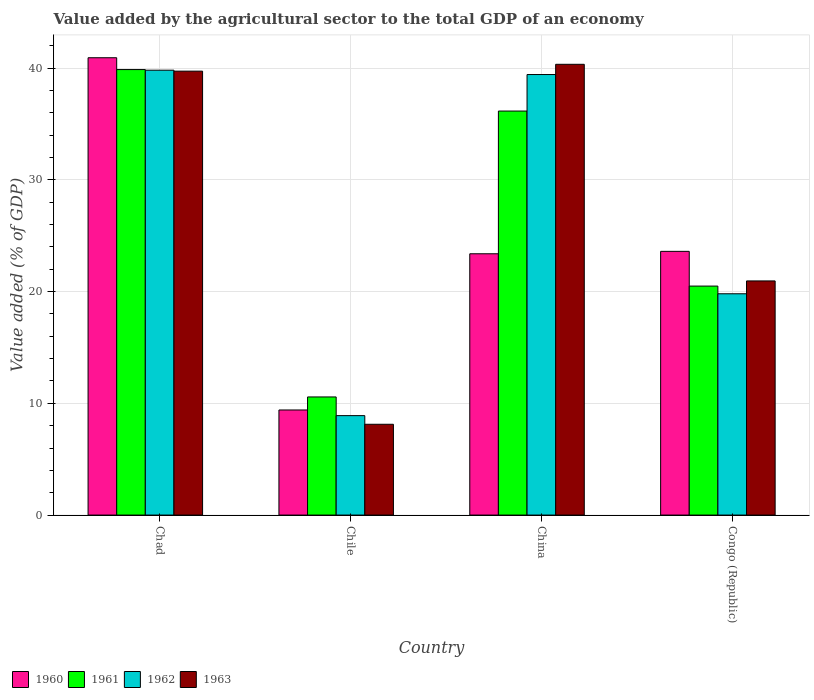How many groups of bars are there?
Provide a short and direct response. 4. How many bars are there on the 1st tick from the right?
Offer a terse response. 4. What is the label of the 1st group of bars from the left?
Provide a succinct answer. Chad. In how many cases, is the number of bars for a given country not equal to the number of legend labels?
Offer a terse response. 0. What is the value added by the agricultural sector to the total GDP in 1963 in Chad?
Provide a short and direct response. 39.73. Across all countries, what is the maximum value added by the agricultural sector to the total GDP in 1961?
Ensure brevity in your answer.  39.87. Across all countries, what is the minimum value added by the agricultural sector to the total GDP in 1963?
Make the answer very short. 8.13. In which country was the value added by the agricultural sector to the total GDP in 1960 maximum?
Your response must be concise. Chad. In which country was the value added by the agricultural sector to the total GDP in 1960 minimum?
Your answer should be compact. Chile. What is the total value added by the agricultural sector to the total GDP in 1962 in the graph?
Your response must be concise. 107.94. What is the difference between the value added by the agricultural sector to the total GDP in 1962 in Chad and that in Chile?
Provide a short and direct response. 30.91. What is the difference between the value added by the agricultural sector to the total GDP in 1963 in Congo (Republic) and the value added by the agricultural sector to the total GDP in 1962 in China?
Keep it short and to the point. -18.47. What is the average value added by the agricultural sector to the total GDP in 1963 per country?
Keep it short and to the point. 27.29. What is the difference between the value added by the agricultural sector to the total GDP of/in 1961 and value added by the agricultural sector to the total GDP of/in 1960 in China?
Give a very brief answer. 12.77. What is the ratio of the value added by the agricultural sector to the total GDP in 1963 in China to that in Congo (Republic)?
Make the answer very short. 1.93. Is the difference between the value added by the agricultural sector to the total GDP in 1961 in Chad and Congo (Republic) greater than the difference between the value added by the agricultural sector to the total GDP in 1960 in Chad and Congo (Republic)?
Your answer should be very brief. Yes. What is the difference between the highest and the second highest value added by the agricultural sector to the total GDP in 1961?
Your answer should be very brief. 15.66. What is the difference between the highest and the lowest value added by the agricultural sector to the total GDP in 1963?
Offer a terse response. 32.21. Is it the case that in every country, the sum of the value added by the agricultural sector to the total GDP in 1962 and value added by the agricultural sector to the total GDP in 1963 is greater than the sum of value added by the agricultural sector to the total GDP in 1961 and value added by the agricultural sector to the total GDP in 1960?
Provide a succinct answer. No. How many countries are there in the graph?
Your response must be concise. 4. What is the difference between two consecutive major ticks on the Y-axis?
Provide a succinct answer. 10. What is the title of the graph?
Give a very brief answer. Value added by the agricultural sector to the total GDP of an economy. Does "2009" appear as one of the legend labels in the graph?
Ensure brevity in your answer.  No. What is the label or title of the X-axis?
Your answer should be compact. Country. What is the label or title of the Y-axis?
Your answer should be compact. Value added (% of GDP). What is the Value added (% of GDP) in 1960 in Chad?
Provide a succinct answer. 40.93. What is the Value added (% of GDP) in 1961 in Chad?
Your answer should be compact. 39.87. What is the Value added (% of GDP) of 1962 in Chad?
Make the answer very short. 39.81. What is the Value added (% of GDP) of 1963 in Chad?
Your response must be concise. 39.73. What is the Value added (% of GDP) of 1960 in Chile?
Provide a short and direct response. 9.4. What is the Value added (% of GDP) in 1961 in Chile?
Offer a terse response. 10.57. What is the Value added (% of GDP) in 1962 in Chile?
Provide a short and direct response. 8.9. What is the Value added (% of GDP) of 1963 in Chile?
Give a very brief answer. 8.13. What is the Value added (% of GDP) of 1960 in China?
Your answer should be compact. 23.38. What is the Value added (% of GDP) in 1961 in China?
Provide a short and direct response. 36.16. What is the Value added (% of GDP) of 1962 in China?
Ensure brevity in your answer.  39.42. What is the Value added (% of GDP) in 1963 in China?
Provide a succinct answer. 40.34. What is the Value added (% of GDP) of 1960 in Congo (Republic)?
Your answer should be very brief. 23.6. What is the Value added (% of GDP) in 1961 in Congo (Republic)?
Provide a short and direct response. 20.49. What is the Value added (% of GDP) in 1962 in Congo (Republic)?
Provide a short and direct response. 19.8. What is the Value added (% of GDP) in 1963 in Congo (Republic)?
Your response must be concise. 20.95. Across all countries, what is the maximum Value added (% of GDP) in 1960?
Ensure brevity in your answer.  40.93. Across all countries, what is the maximum Value added (% of GDP) in 1961?
Ensure brevity in your answer.  39.87. Across all countries, what is the maximum Value added (% of GDP) in 1962?
Make the answer very short. 39.81. Across all countries, what is the maximum Value added (% of GDP) of 1963?
Provide a succinct answer. 40.34. Across all countries, what is the minimum Value added (% of GDP) of 1960?
Make the answer very short. 9.4. Across all countries, what is the minimum Value added (% of GDP) in 1961?
Your answer should be very brief. 10.57. Across all countries, what is the minimum Value added (% of GDP) in 1962?
Provide a succinct answer. 8.9. Across all countries, what is the minimum Value added (% of GDP) in 1963?
Your answer should be very brief. 8.13. What is the total Value added (% of GDP) of 1960 in the graph?
Provide a short and direct response. 97.32. What is the total Value added (% of GDP) in 1961 in the graph?
Offer a very short reply. 107.09. What is the total Value added (% of GDP) in 1962 in the graph?
Provide a succinct answer. 107.94. What is the total Value added (% of GDP) of 1963 in the graph?
Your response must be concise. 109.15. What is the difference between the Value added (% of GDP) in 1960 in Chad and that in Chile?
Ensure brevity in your answer.  31.52. What is the difference between the Value added (% of GDP) in 1961 in Chad and that in Chile?
Offer a terse response. 29.3. What is the difference between the Value added (% of GDP) in 1962 in Chad and that in Chile?
Provide a succinct answer. 30.91. What is the difference between the Value added (% of GDP) in 1963 in Chad and that in Chile?
Provide a short and direct response. 31.6. What is the difference between the Value added (% of GDP) in 1960 in Chad and that in China?
Give a very brief answer. 17.54. What is the difference between the Value added (% of GDP) in 1961 in Chad and that in China?
Offer a very short reply. 3.71. What is the difference between the Value added (% of GDP) in 1962 in Chad and that in China?
Provide a short and direct response. 0.39. What is the difference between the Value added (% of GDP) of 1963 in Chad and that in China?
Keep it short and to the point. -0.61. What is the difference between the Value added (% of GDP) in 1960 in Chad and that in Congo (Republic)?
Provide a succinct answer. 17.33. What is the difference between the Value added (% of GDP) in 1961 in Chad and that in Congo (Republic)?
Make the answer very short. 19.38. What is the difference between the Value added (% of GDP) in 1962 in Chad and that in Congo (Republic)?
Your answer should be compact. 20.01. What is the difference between the Value added (% of GDP) in 1963 in Chad and that in Congo (Republic)?
Your answer should be very brief. 18.77. What is the difference between the Value added (% of GDP) of 1960 in Chile and that in China?
Ensure brevity in your answer.  -13.98. What is the difference between the Value added (% of GDP) of 1961 in Chile and that in China?
Make the answer very short. -25.58. What is the difference between the Value added (% of GDP) in 1962 in Chile and that in China?
Make the answer very short. -30.52. What is the difference between the Value added (% of GDP) in 1963 in Chile and that in China?
Make the answer very short. -32.21. What is the difference between the Value added (% of GDP) of 1960 in Chile and that in Congo (Republic)?
Provide a short and direct response. -14.2. What is the difference between the Value added (% of GDP) of 1961 in Chile and that in Congo (Republic)?
Offer a very short reply. -9.92. What is the difference between the Value added (% of GDP) in 1962 in Chile and that in Congo (Republic)?
Provide a short and direct response. -10.91. What is the difference between the Value added (% of GDP) in 1963 in Chile and that in Congo (Republic)?
Provide a succinct answer. -12.83. What is the difference between the Value added (% of GDP) in 1960 in China and that in Congo (Republic)?
Keep it short and to the point. -0.22. What is the difference between the Value added (% of GDP) in 1961 in China and that in Congo (Republic)?
Your answer should be compact. 15.66. What is the difference between the Value added (% of GDP) in 1962 in China and that in Congo (Republic)?
Provide a short and direct response. 19.62. What is the difference between the Value added (% of GDP) in 1963 in China and that in Congo (Republic)?
Keep it short and to the point. 19.38. What is the difference between the Value added (% of GDP) of 1960 in Chad and the Value added (% of GDP) of 1961 in Chile?
Provide a short and direct response. 30.36. What is the difference between the Value added (% of GDP) of 1960 in Chad and the Value added (% of GDP) of 1962 in Chile?
Provide a succinct answer. 32.03. What is the difference between the Value added (% of GDP) in 1960 in Chad and the Value added (% of GDP) in 1963 in Chile?
Provide a short and direct response. 32.8. What is the difference between the Value added (% of GDP) in 1961 in Chad and the Value added (% of GDP) in 1962 in Chile?
Offer a terse response. 30.97. What is the difference between the Value added (% of GDP) of 1961 in Chad and the Value added (% of GDP) of 1963 in Chile?
Give a very brief answer. 31.74. What is the difference between the Value added (% of GDP) in 1962 in Chad and the Value added (% of GDP) in 1963 in Chile?
Ensure brevity in your answer.  31.69. What is the difference between the Value added (% of GDP) of 1960 in Chad and the Value added (% of GDP) of 1961 in China?
Offer a terse response. 4.77. What is the difference between the Value added (% of GDP) in 1960 in Chad and the Value added (% of GDP) in 1962 in China?
Provide a short and direct response. 1.5. What is the difference between the Value added (% of GDP) of 1960 in Chad and the Value added (% of GDP) of 1963 in China?
Make the answer very short. 0.59. What is the difference between the Value added (% of GDP) in 1961 in Chad and the Value added (% of GDP) in 1962 in China?
Give a very brief answer. 0.44. What is the difference between the Value added (% of GDP) of 1961 in Chad and the Value added (% of GDP) of 1963 in China?
Your answer should be compact. -0.47. What is the difference between the Value added (% of GDP) in 1962 in Chad and the Value added (% of GDP) in 1963 in China?
Provide a short and direct response. -0.53. What is the difference between the Value added (% of GDP) of 1960 in Chad and the Value added (% of GDP) of 1961 in Congo (Republic)?
Your answer should be very brief. 20.44. What is the difference between the Value added (% of GDP) in 1960 in Chad and the Value added (% of GDP) in 1962 in Congo (Republic)?
Your answer should be compact. 21.12. What is the difference between the Value added (% of GDP) of 1960 in Chad and the Value added (% of GDP) of 1963 in Congo (Republic)?
Keep it short and to the point. 19.97. What is the difference between the Value added (% of GDP) of 1961 in Chad and the Value added (% of GDP) of 1962 in Congo (Republic)?
Provide a short and direct response. 20.06. What is the difference between the Value added (% of GDP) in 1961 in Chad and the Value added (% of GDP) in 1963 in Congo (Republic)?
Keep it short and to the point. 18.91. What is the difference between the Value added (% of GDP) of 1962 in Chad and the Value added (% of GDP) of 1963 in Congo (Republic)?
Keep it short and to the point. 18.86. What is the difference between the Value added (% of GDP) of 1960 in Chile and the Value added (% of GDP) of 1961 in China?
Provide a short and direct response. -26.75. What is the difference between the Value added (% of GDP) of 1960 in Chile and the Value added (% of GDP) of 1962 in China?
Give a very brief answer. -30.02. What is the difference between the Value added (% of GDP) in 1960 in Chile and the Value added (% of GDP) in 1963 in China?
Make the answer very short. -30.93. What is the difference between the Value added (% of GDP) of 1961 in Chile and the Value added (% of GDP) of 1962 in China?
Your answer should be very brief. -28.85. What is the difference between the Value added (% of GDP) in 1961 in Chile and the Value added (% of GDP) in 1963 in China?
Keep it short and to the point. -29.77. What is the difference between the Value added (% of GDP) in 1962 in Chile and the Value added (% of GDP) in 1963 in China?
Provide a short and direct response. -31.44. What is the difference between the Value added (% of GDP) in 1960 in Chile and the Value added (% of GDP) in 1961 in Congo (Republic)?
Your answer should be very brief. -11.09. What is the difference between the Value added (% of GDP) in 1960 in Chile and the Value added (% of GDP) in 1962 in Congo (Republic)?
Give a very brief answer. -10.4. What is the difference between the Value added (% of GDP) of 1960 in Chile and the Value added (% of GDP) of 1963 in Congo (Republic)?
Provide a short and direct response. -11.55. What is the difference between the Value added (% of GDP) of 1961 in Chile and the Value added (% of GDP) of 1962 in Congo (Republic)?
Ensure brevity in your answer.  -9.23. What is the difference between the Value added (% of GDP) of 1961 in Chile and the Value added (% of GDP) of 1963 in Congo (Republic)?
Your answer should be very brief. -10.38. What is the difference between the Value added (% of GDP) in 1962 in Chile and the Value added (% of GDP) in 1963 in Congo (Republic)?
Offer a terse response. -12.05. What is the difference between the Value added (% of GDP) in 1960 in China and the Value added (% of GDP) in 1961 in Congo (Republic)?
Ensure brevity in your answer.  2.89. What is the difference between the Value added (% of GDP) in 1960 in China and the Value added (% of GDP) in 1962 in Congo (Republic)?
Make the answer very short. 3.58. What is the difference between the Value added (% of GDP) of 1960 in China and the Value added (% of GDP) of 1963 in Congo (Republic)?
Offer a terse response. 2.43. What is the difference between the Value added (% of GDP) of 1961 in China and the Value added (% of GDP) of 1962 in Congo (Republic)?
Your answer should be very brief. 16.35. What is the difference between the Value added (% of GDP) in 1961 in China and the Value added (% of GDP) in 1963 in Congo (Republic)?
Ensure brevity in your answer.  15.2. What is the difference between the Value added (% of GDP) in 1962 in China and the Value added (% of GDP) in 1963 in Congo (Republic)?
Provide a short and direct response. 18.47. What is the average Value added (% of GDP) in 1960 per country?
Your response must be concise. 24.33. What is the average Value added (% of GDP) in 1961 per country?
Give a very brief answer. 26.77. What is the average Value added (% of GDP) in 1962 per country?
Your answer should be very brief. 26.98. What is the average Value added (% of GDP) in 1963 per country?
Ensure brevity in your answer.  27.29. What is the difference between the Value added (% of GDP) in 1960 and Value added (% of GDP) in 1961 in Chad?
Make the answer very short. 1.06. What is the difference between the Value added (% of GDP) in 1960 and Value added (% of GDP) in 1962 in Chad?
Ensure brevity in your answer.  1.11. What is the difference between the Value added (% of GDP) of 1960 and Value added (% of GDP) of 1963 in Chad?
Offer a terse response. 1.2. What is the difference between the Value added (% of GDP) of 1961 and Value added (% of GDP) of 1962 in Chad?
Keep it short and to the point. 0.06. What is the difference between the Value added (% of GDP) of 1961 and Value added (% of GDP) of 1963 in Chad?
Your response must be concise. 0.14. What is the difference between the Value added (% of GDP) in 1962 and Value added (% of GDP) in 1963 in Chad?
Offer a terse response. 0.09. What is the difference between the Value added (% of GDP) of 1960 and Value added (% of GDP) of 1961 in Chile?
Your answer should be very brief. -1.17. What is the difference between the Value added (% of GDP) in 1960 and Value added (% of GDP) in 1962 in Chile?
Your answer should be compact. 0.51. What is the difference between the Value added (% of GDP) in 1960 and Value added (% of GDP) in 1963 in Chile?
Ensure brevity in your answer.  1.28. What is the difference between the Value added (% of GDP) in 1961 and Value added (% of GDP) in 1962 in Chile?
Give a very brief answer. 1.67. What is the difference between the Value added (% of GDP) of 1961 and Value added (% of GDP) of 1963 in Chile?
Provide a short and direct response. 2.45. What is the difference between the Value added (% of GDP) in 1962 and Value added (% of GDP) in 1963 in Chile?
Your answer should be compact. 0.77. What is the difference between the Value added (% of GDP) in 1960 and Value added (% of GDP) in 1961 in China?
Your response must be concise. -12.77. What is the difference between the Value added (% of GDP) in 1960 and Value added (% of GDP) in 1962 in China?
Keep it short and to the point. -16.04. What is the difference between the Value added (% of GDP) in 1960 and Value added (% of GDP) in 1963 in China?
Your answer should be very brief. -16.96. What is the difference between the Value added (% of GDP) in 1961 and Value added (% of GDP) in 1962 in China?
Offer a terse response. -3.27. What is the difference between the Value added (% of GDP) of 1961 and Value added (% of GDP) of 1963 in China?
Provide a short and direct response. -4.18. What is the difference between the Value added (% of GDP) of 1962 and Value added (% of GDP) of 1963 in China?
Your answer should be very brief. -0.91. What is the difference between the Value added (% of GDP) of 1960 and Value added (% of GDP) of 1961 in Congo (Republic)?
Your answer should be very brief. 3.11. What is the difference between the Value added (% of GDP) of 1960 and Value added (% of GDP) of 1962 in Congo (Republic)?
Provide a succinct answer. 3.8. What is the difference between the Value added (% of GDP) in 1960 and Value added (% of GDP) in 1963 in Congo (Republic)?
Offer a very short reply. 2.65. What is the difference between the Value added (% of GDP) of 1961 and Value added (% of GDP) of 1962 in Congo (Republic)?
Provide a succinct answer. 0.69. What is the difference between the Value added (% of GDP) in 1961 and Value added (% of GDP) in 1963 in Congo (Republic)?
Ensure brevity in your answer.  -0.46. What is the difference between the Value added (% of GDP) of 1962 and Value added (% of GDP) of 1963 in Congo (Republic)?
Offer a very short reply. -1.15. What is the ratio of the Value added (% of GDP) in 1960 in Chad to that in Chile?
Give a very brief answer. 4.35. What is the ratio of the Value added (% of GDP) of 1961 in Chad to that in Chile?
Your answer should be compact. 3.77. What is the ratio of the Value added (% of GDP) of 1962 in Chad to that in Chile?
Provide a succinct answer. 4.47. What is the ratio of the Value added (% of GDP) in 1963 in Chad to that in Chile?
Give a very brief answer. 4.89. What is the ratio of the Value added (% of GDP) of 1960 in Chad to that in China?
Provide a short and direct response. 1.75. What is the ratio of the Value added (% of GDP) in 1961 in Chad to that in China?
Provide a succinct answer. 1.1. What is the ratio of the Value added (% of GDP) in 1962 in Chad to that in China?
Ensure brevity in your answer.  1.01. What is the ratio of the Value added (% of GDP) in 1960 in Chad to that in Congo (Republic)?
Your answer should be compact. 1.73. What is the ratio of the Value added (% of GDP) of 1961 in Chad to that in Congo (Republic)?
Give a very brief answer. 1.95. What is the ratio of the Value added (% of GDP) of 1962 in Chad to that in Congo (Republic)?
Your answer should be compact. 2.01. What is the ratio of the Value added (% of GDP) in 1963 in Chad to that in Congo (Republic)?
Offer a very short reply. 1.9. What is the ratio of the Value added (% of GDP) of 1960 in Chile to that in China?
Your answer should be compact. 0.4. What is the ratio of the Value added (% of GDP) of 1961 in Chile to that in China?
Your answer should be very brief. 0.29. What is the ratio of the Value added (% of GDP) of 1962 in Chile to that in China?
Your response must be concise. 0.23. What is the ratio of the Value added (% of GDP) in 1963 in Chile to that in China?
Provide a short and direct response. 0.2. What is the ratio of the Value added (% of GDP) of 1960 in Chile to that in Congo (Republic)?
Your answer should be very brief. 0.4. What is the ratio of the Value added (% of GDP) of 1961 in Chile to that in Congo (Republic)?
Offer a very short reply. 0.52. What is the ratio of the Value added (% of GDP) of 1962 in Chile to that in Congo (Republic)?
Give a very brief answer. 0.45. What is the ratio of the Value added (% of GDP) of 1963 in Chile to that in Congo (Republic)?
Make the answer very short. 0.39. What is the ratio of the Value added (% of GDP) of 1961 in China to that in Congo (Republic)?
Give a very brief answer. 1.76. What is the ratio of the Value added (% of GDP) of 1962 in China to that in Congo (Republic)?
Make the answer very short. 1.99. What is the ratio of the Value added (% of GDP) of 1963 in China to that in Congo (Republic)?
Keep it short and to the point. 1.93. What is the difference between the highest and the second highest Value added (% of GDP) of 1960?
Provide a succinct answer. 17.33. What is the difference between the highest and the second highest Value added (% of GDP) in 1961?
Keep it short and to the point. 3.71. What is the difference between the highest and the second highest Value added (% of GDP) of 1962?
Provide a short and direct response. 0.39. What is the difference between the highest and the second highest Value added (% of GDP) of 1963?
Your response must be concise. 0.61. What is the difference between the highest and the lowest Value added (% of GDP) in 1960?
Your answer should be compact. 31.52. What is the difference between the highest and the lowest Value added (% of GDP) in 1961?
Provide a short and direct response. 29.3. What is the difference between the highest and the lowest Value added (% of GDP) of 1962?
Your answer should be very brief. 30.91. What is the difference between the highest and the lowest Value added (% of GDP) of 1963?
Keep it short and to the point. 32.21. 